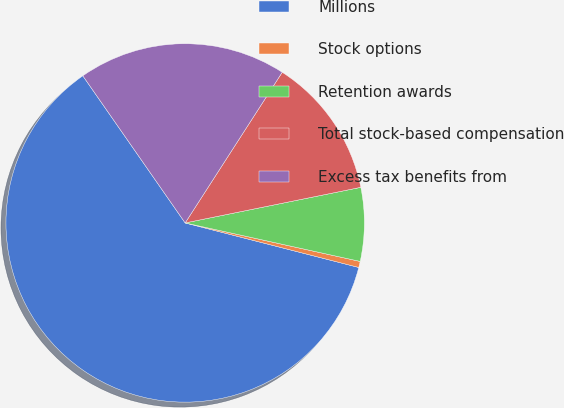Convert chart. <chart><loc_0><loc_0><loc_500><loc_500><pie_chart><fcel>Millions<fcel>Stock options<fcel>Retention awards<fcel>Total stock-based compensation<fcel>Excess tax benefits from<nl><fcel>61.33%<fcel>0.55%<fcel>6.63%<fcel>12.71%<fcel>18.78%<nl></chart> 